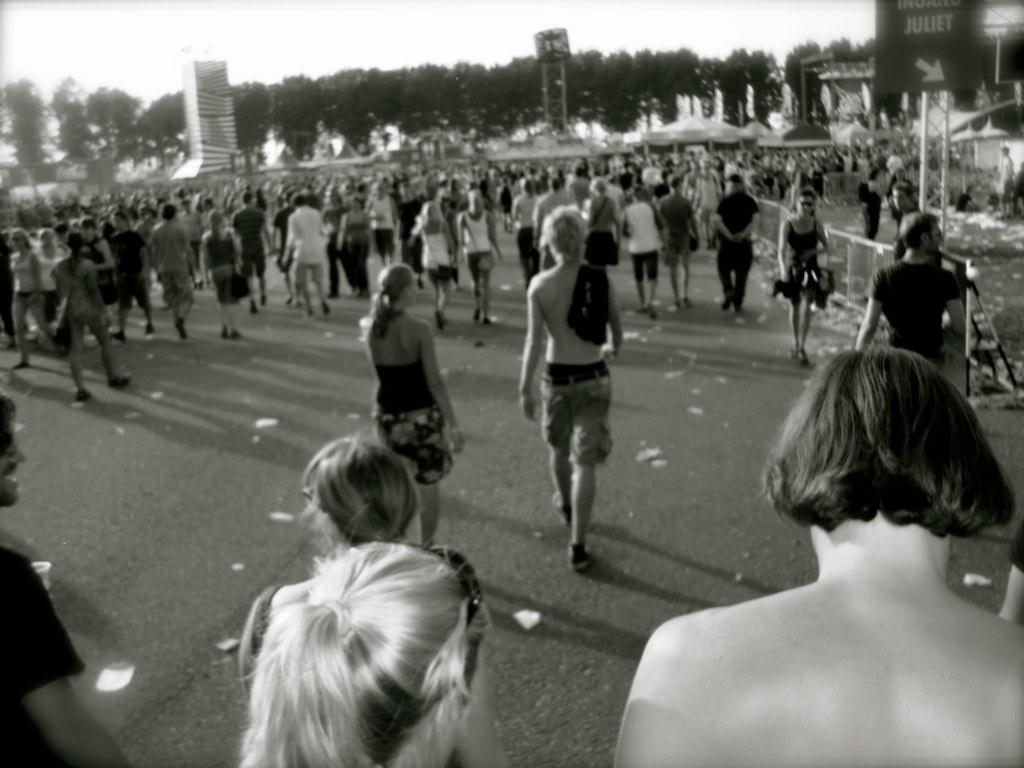What is happening on the road in the image? There is a crowd on the road in the image. What can be seen near the road in the image? There is a fence in the image. What type of vegetation is present in the image? There are trees in the image. What type of structures are visible in the image? There are buildings in the image. What is the board in the image used for? The purpose of the board in the image is not specified, but it could be used for displaying information or advertisements. What is visible in the sky in the image? The sky is visible in the image. Can you tell me how many carpenters are working on the tree in the image? There are no carpenters or trees being worked on in the image. Where is the mailbox located in the image? There is no mailbox present in the image. 